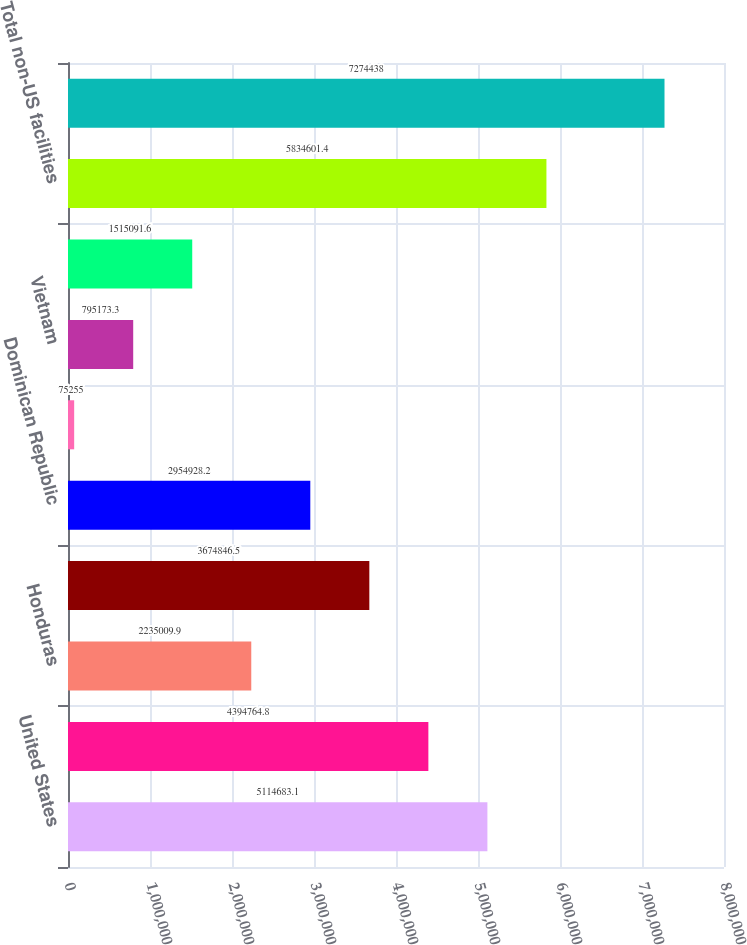Convert chart to OTSL. <chart><loc_0><loc_0><loc_500><loc_500><bar_chart><fcel>United States<fcel>El Salvador<fcel>Honduras<fcel>China<fcel>Dominican Republic<fcel>Mexico<fcel>Vietnam<fcel>Thailand<fcel>Total non-US facilities<fcel>Totals<nl><fcel>5.11468e+06<fcel>4.39476e+06<fcel>2.23501e+06<fcel>3.67485e+06<fcel>2.95493e+06<fcel>75255<fcel>795173<fcel>1.51509e+06<fcel>5.8346e+06<fcel>7.27444e+06<nl></chart> 